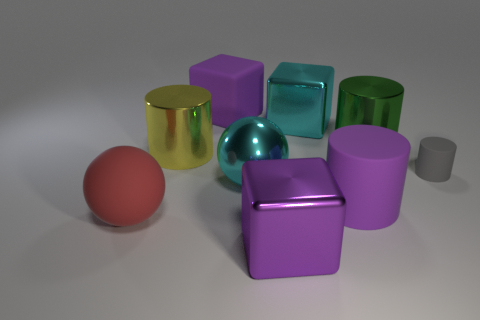Are there the same number of large cyan metal blocks left of the large green shiny cylinder and cubes in front of the red matte object?
Your response must be concise. Yes. What number of spheres are large red things or tiny gray objects?
Give a very brief answer. 1. What number of other objects are there of the same material as the yellow cylinder?
Keep it short and to the point. 4. The purple matte thing on the left side of the big cyan metallic sphere has what shape?
Your response must be concise. Cube. The large purple block that is behind the yellow object to the left of the large green cylinder is made of what material?
Your answer should be very brief. Rubber. Are there more big cubes that are in front of the big red thing than rubber blocks?
Your answer should be compact. No. What number of other objects are the same color as the metal ball?
Keep it short and to the point. 1. What is the shape of the cyan object that is the same size as the metal sphere?
Make the answer very short. Cube. How many large cubes are in front of the large cube that is in front of the cyan shiny thing behind the green thing?
Offer a very short reply. 0. What number of matte things are either blue spheres or purple cylinders?
Your answer should be very brief. 1. 